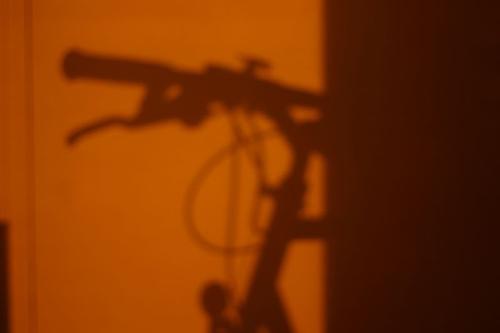Are these pictures duplicates?
Write a very short answer. No. What is in the picture?
Keep it brief. Bicycle. Is the shadow from a fixie?
Quick response, please. No. What shadow is being cast?
Answer briefly. Bicycle. What causes a shadow to be cast?
Give a very brief answer. Light. Where are the people at?
Keep it brief. No people. 